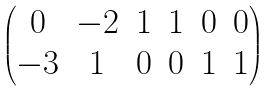Convert formula to latex. <formula><loc_0><loc_0><loc_500><loc_500>\begin{pmatrix} 0 & - 2 & 1 & 1 & 0 & 0 \\ - 3 & 1 & 0 & 0 & 1 & 1 \end{pmatrix}</formula> 